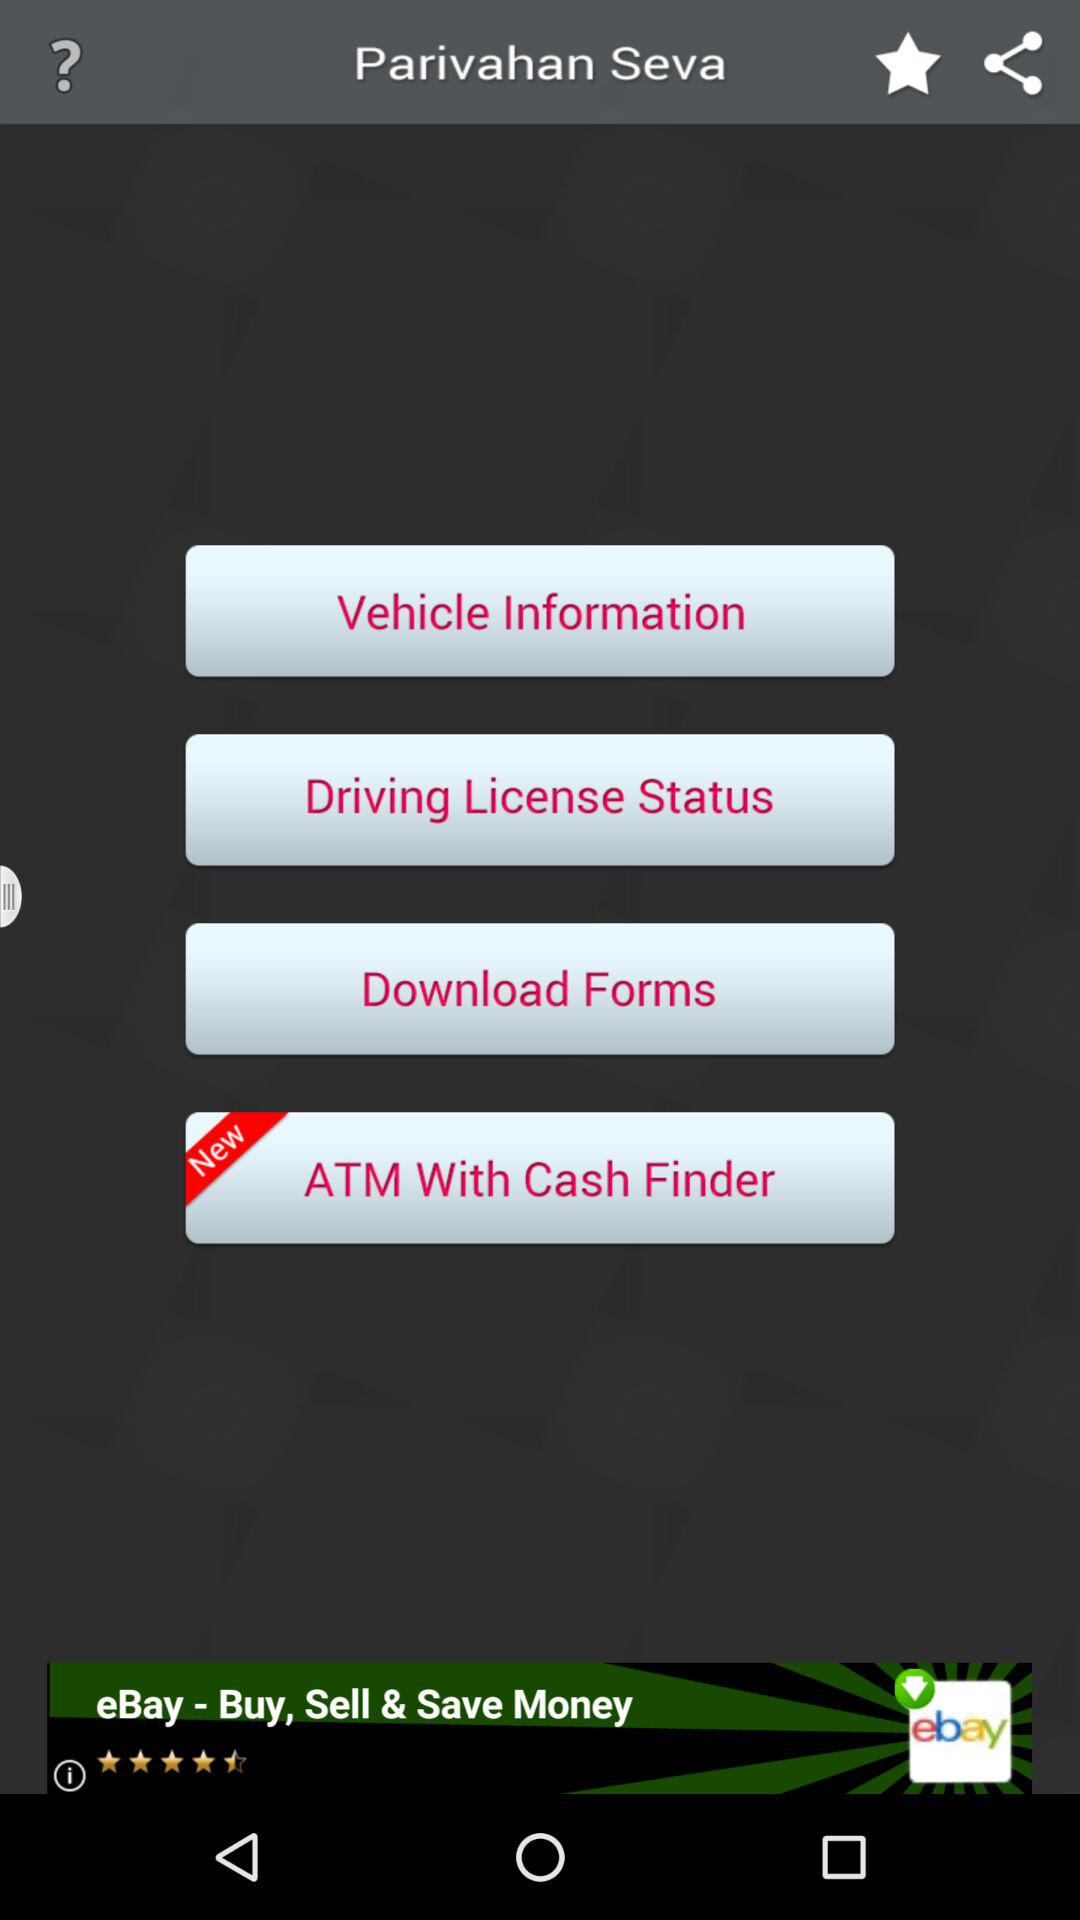What is the application name? The application name is "Parivahan Seva". 